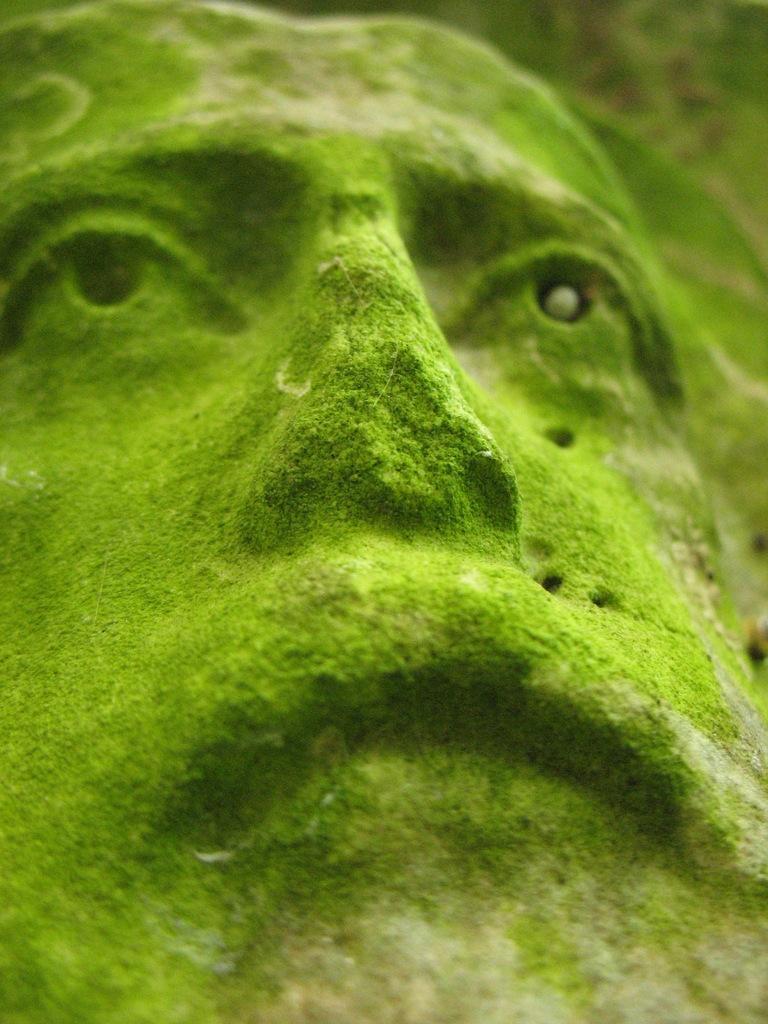In one or two sentences, can you explain what this image depicts? In this picture there is a statue face in the image. 